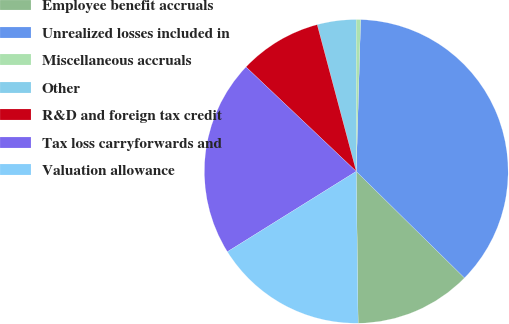<chart> <loc_0><loc_0><loc_500><loc_500><pie_chart><fcel>Employee benefit accruals<fcel>Unrealized losses included in<fcel>Miscellaneous accruals<fcel>Other<fcel>R&D and foreign tax credit<fcel>Tax loss carryforwards and<fcel>Valuation allowance<nl><fcel>12.43%<fcel>36.91%<fcel>0.48%<fcel>4.12%<fcel>8.79%<fcel>20.94%<fcel>16.32%<nl></chart> 